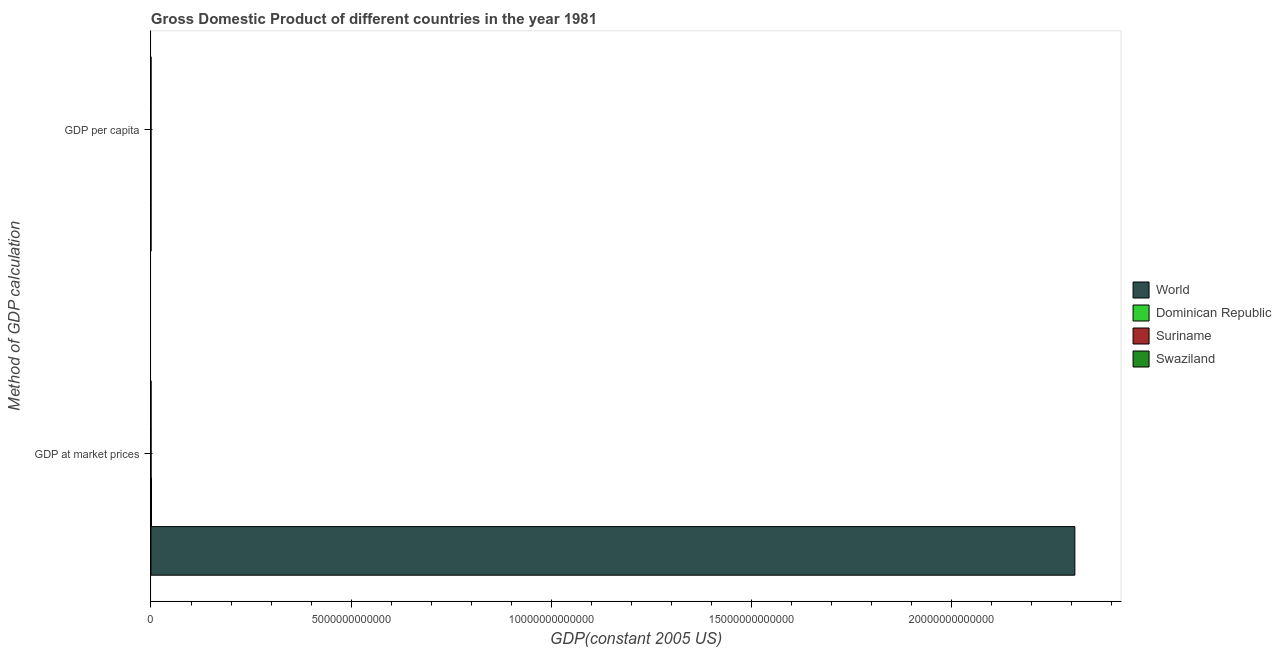How many different coloured bars are there?
Ensure brevity in your answer.  4. Are the number of bars on each tick of the Y-axis equal?
Offer a very short reply. Yes. How many bars are there on the 1st tick from the top?
Your answer should be very brief. 4. What is the label of the 2nd group of bars from the top?
Your answer should be compact. GDP at market prices. What is the gdp at market prices in Swaziland?
Your answer should be compact. 8.23e+08. Across all countries, what is the maximum gdp at market prices?
Ensure brevity in your answer.  2.31e+13. Across all countries, what is the minimum gdp at market prices?
Ensure brevity in your answer.  8.23e+08. In which country was the gdp per capita minimum?
Give a very brief answer. Swaziland. What is the total gdp per capita in the graph?
Give a very brief answer. 1.26e+04. What is the difference between the gdp at market prices in World and that in Suriname?
Your answer should be very brief. 2.31e+13. What is the difference between the gdp per capita in World and the gdp at market prices in Swaziland?
Make the answer very short. -8.23e+08. What is the average gdp at market prices per country?
Make the answer very short. 5.77e+12. What is the difference between the gdp at market prices and gdp per capita in Swaziland?
Provide a short and direct response. 8.23e+08. What is the ratio of the gdp per capita in World to that in Swaziland?
Offer a terse response. 3.86. In how many countries, is the gdp per capita greater than the average gdp per capita taken over all countries?
Offer a terse response. 2. What does the 2nd bar from the top in GDP per capita represents?
Provide a short and direct response. Suriname. What does the 3rd bar from the bottom in GDP per capita represents?
Offer a very short reply. Suriname. How many bars are there?
Make the answer very short. 8. How many countries are there in the graph?
Your response must be concise. 4. What is the difference between two consecutive major ticks on the X-axis?
Provide a short and direct response. 5.00e+12. Does the graph contain any zero values?
Provide a succinct answer. No. Where does the legend appear in the graph?
Make the answer very short. Center right. How many legend labels are there?
Your response must be concise. 4. How are the legend labels stacked?
Provide a succinct answer. Vertical. What is the title of the graph?
Your answer should be very brief. Gross Domestic Product of different countries in the year 1981. Does "Andorra" appear as one of the legend labels in the graph?
Your response must be concise. No. What is the label or title of the X-axis?
Give a very brief answer. GDP(constant 2005 US). What is the label or title of the Y-axis?
Offer a very short reply. Method of GDP calculation. What is the GDP(constant 2005 US) in World in GDP at market prices?
Your response must be concise. 2.31e+13. What is the GDP(constant 2005 US) in Dominican Republic in GDP at market prices?
Ensure brevity in your answer.  1.31e+1. What is the GDP(constant 2005 US) in Suriname in GDP at market prices?
Offer a very short reply. 1.42e+09. What is the GDP(constant 2005 US) in Swaziland in GDP at market prices?
Give a very brief answer. 8.23e+08. What is the GDP(constant 2005 US) in World in GDP per capita?
Ensure brevity in your answer.  5111.41. What is the GDP(constant 2005 US) in Dominican Republic in GDP per capita?
Provide a short and direct response. 2202.27. What is the GDP(constant 2005 US) in Suriname in GDP per capita?
Make the answer very short. 3919.95. What is the GDP(constant 2005 US) of Swaziland in GDP per capita?
Provide a succinct answer. 1324.99. Across all Method of GDP calculation, what is the maximum GDP(constant 2005 US) of World?
Give a very brief answer. 2.31e+13. Across all Method of GDP calculation, what is the maximum GDP(constant 2005 US) in Dominican Republic?
Provide a short and direct response. 1.31e+1. Across all Method of GDP calculation, what is the maximum GDP(constant 2005 US) in Suriname?
Make the answer very short. 1.42e+09. Across all Method of GDP calculation, what is the maximum GDP(constant 2005 US) in Swaziland?
Your answer should be very brief. 8.23e+08. Across all Method of GDP calculation, what is the minimum GDP(constant 2005 US) of World?
Offer a very short reply. 5111.41. Across all Method of GDP calculation, what is the minimum GDP(constant 2005 US) in Dominican Republic?
Ensure brevity in your answer.  2202.27. Across all Method of GDP calculation, what is the minimum GDP(constant 2005 US) of Suriname?
Ensure brevity in your answer.  3919.95. Across all Method of GDP calculation, what is the minimum GDP(constant 2005 US) of Swaziland?
Offer a very short reply. 1324.99. What is the total GDP(constant 2005 US) in World in the graph?
Offer a terse response. 2.31e+13. What is the total GDP(constant 2005 US) in Dominican Republic in the graph?
Make the answer very short. 1.31e+1. What is the total GDP(constant 2005 US) of Suriname in the graph?
Keep it short and to the point. 1.42e+09. What is the total GDP(constant 2005 US) of Swaziland in the graph?
Make the answer very short. 8.23e+08. What is the difference between the GDP(constant 2005 US) in World in GDP at market prices and that in GDP per capita?
Make the answer very short. 2.31e+13. What is the difference between the GDP(constant 2005 US) of Dominican Republic in GDP at market prices and that in GDP per capita?
Provide a succinct answer. 1.31e+1. What is the difference between the GDP(constant 2005 US) in Suriname in GDP at market prices and that in GDP per capita?
Make the answer very short. 1.42e+09. What is the difference between the GDP(constant 2005 US) of Swaziland in GDP at market prices and that in GDP per capita?
Provide a short and direct response. 8.23e+08. What is the difference between the GDP(constant 2005 US) in World in GDP at market prices and the GDP(constant 2005 US) in Dominican Republic in GDP per capita?
Your response must be concise. 2.31e+13. What is the difference between the GDP(constant 2005 US) in World in GDP at market prices and the GDP(constant 2005 US) in Suriname in GDP per capita?
Your answer should be compact. 2.31e+13. What is the difference between the GDP(constant 2005 US) of World in GDP at market prices and the GDP(constant 2005 US) of Swaziland in GDP per capita?
Provide a short and direct response. 2.31e+13. What is the difference between the GDP(constant 2005 US) in Dominican Republic in GDP at market prices and the GDP(constant 2005 US) in Suriname in GDP per capita?
Make the answer very short. 1.31e+1. What is the difference between the GDP(constant 2005 US) in Dominican Republic in GDP at market prices and the GDP(constant 2005 US) in Swaziland in GDP per capita?
Your response must be concise. 1.31e+1. What is the difference between the GDP(constant 2005 US) in Suriname in GDP at market prices and the GDP(constant 2005 US) in Swaziland in GDP per capita?
Your response must be concise. 1.42e+09. What is the average GDP(constant 2005 US) in World per Method of GDP calculation?
Provide a short and direct response. 1.15e+13. What is the average GDP(constant 2005 US) of Dominican Republic per Method of GDP calculation?
Your response must be concise. 6.54e+09. What is the average GDP(constant 2005 US) in Suriname per Method of GDP calculation?
Give a very brief answer. 7.12e+08. What is the average GDP(constant 2005 US) in Swaziland per Method of GDP calculation?
Provide a succinct answer. 4.12e+08. What is the difference between the GDP(constant 2005 US) of World and GDP(constant 2005 US) of Dominican Republic in GDP at market prices?
Give a very brief answer. 2.31e+13. What is the difference between the GDP(constant 2005 US) in World and GDP(constant 2005 US) in Suriname in GDP at market prices?
Provide a succinct answer. 2.31e+13. What is the difference between the GDP(constant 2005 US) in World and GDP(constant 2005 US) in Swaziland in GDP at market prices?
Ensure brevity in your answer.  2.31e+13. What is the difference between the GDP(constant 2005 US) in Dominican Republic and GDP(constant 2005 US) in Suriname in GDP at market prices?
Give a very brief answer. 1.17e+1. What is the difference between the GDP(constant 2005 US) in Dominican Republic and GDP(constant 2005 US) in Swaziland in GDP at market prices?
Your response must be concise. 1.23e+1. What is the difference between the GDP(constant 2005 US) in Suriname and GDP(constant 2005 US) in Swaziland in GDP at market prices?
Keep it short and to the point. 6.01e+08. What is the difference between the GDP(constant 2005 US) of World and GDP(constant 2005 US) of Dominican Republic in GDP per capita?
Keep it short and to the point. 2909.14. What is the difference between the GDP(constant 2005 US) in World and GDP(constant 2005 US) in Suriname in GDP per capita?
Keep it short and to the point. 1191.46. What is the difference between the GDP(constant 2005 US) of World and GDP(constant 2005 US) of Swaziland in GDP per capita?
Your response must be concise. 3786.42. What is the difference between the GDP(constant 2005 US) of Dominican Republic and GDP(constant 2005 US) of Suriname in GDP per capita?
Provide a succinct answer. -1717.68. What is the difference between the GDP(constant 2005 US) in Dominican Republic and GDP(constant 2005 US) in Swaziland in GDP per capita?
Your answer should be compact. 877.28. What is the difference between the GDP(constant 2005 US) of Suriname and GDP(constant 2005 US) of Swaziland in GDP per capita?
Give a very brief answer. 2594.96. What is the ratio of the GDP(constant 2005 US) in World in GDP at market prices to that in GDP per capita?
Give a very brief answer. 4.51e+09. What is the ratio of the GDP(constant 2005 US) in Dominican Republic in GDP at market prices to that in GDP per capita?
Offer a terse response. 5.94e+06. What is the ratio of the GDP(constant 2005 US) in Suriname in GDP at market prices to that in GDP per capita?
Make the answer very short. 3.63e+05. What is the ratio of the GDP(constant 2005 US) of Swaziland in GDP at market prices to that in GDP per capita?
Offer a very short reply. 6.21e+05. What is the difference between the highest and the second highest GDP(constant 2005 US) of World?
Your answer should be compact. 2.31e+13. What is the difference between the highest and the second highest GDP(constant 2005 US) of Dominican Republic?
Your answer should be compact. 1.31e+1. What is the difference between the highest and the second highest GDP(constant 2005 US) in Suriname?
Offer a terse response. 1.42e+09. What is the difference between the highest and the second highest GDP(constant 2005 US) of Swaziland?
Your response must be concise. 8.23e+08. What is the difference between the highest and the lowest GDP(constant 2005 US) in World?
Your response must be concise. 2.31e+13. What is the difference between the highest and the lowest GDP(constant 2005 US) in Dominican Republic?
Keep it short and to the point. 1.31e+1. What is the difference between the highest and the lowest GDP(constant 2005 US) in Suriname?
Offer a very short reply. 1.42e+09. What is the difference between the highest and the lowest GDP(constant 2005 US) of Swaziland?
Offer a very short reply. 8.23e+08. 